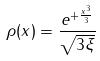Convert formula to latex. <formula><loc_0><loc_0><loc_500><loc_500>\rho ( x ) = \frac { e ^ { + \frac { x ^ { 3 } } { 3 } } } { \sqrt { 3 \xi } }</formula> 